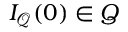Convert formula to latex. <formula><loc_0><loc_0><loc_500><loc_500>I _ { \mathcal { Q } } ( 0 ) \in Q</formula> 